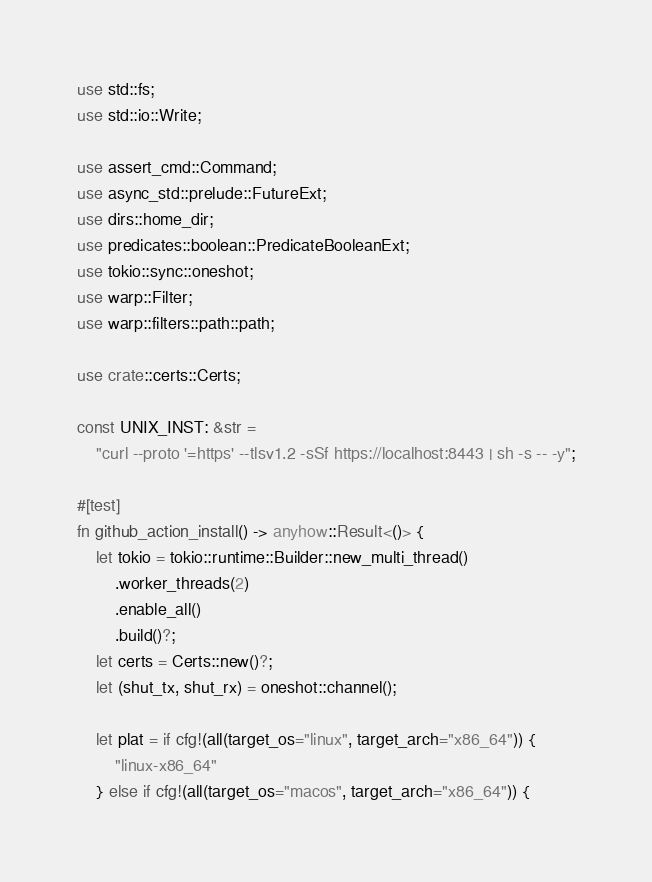Convert code to text. <code><loc_0><loc_0><loc_500><loc_500><_Rust_>use std::fs;
use std::io::Write;

use assert_cmd::Command;
use async_std::prelude::FutureExt;
use dirs::home_dir;
use predicates::boolean::PredicateBooleanExt;
use tokio::sync::oneshot;
use warp::Filter;
use warp::filters::path::path;

use crate::certs::Certs;

const UNIX_INST: &str =
    "curl --proto '=https' --tlsv1.2 -sSf https://localhost:8443 | sh -s -- -y";

#[test]
fn github_action_install() -> anyhow::Result<()> {
    let tokio = tokio::runtime::Builder::new_multi_thread()
        .worker_threads(2)
        .enable_all()
        .build()?;
    let certs = Certs::new()?;
    let (shut_tx, shut_rx) = oneshot::channel();

    let plat = if cfg!(all(target_os="linux", target_arch="x86_64")) {
        "linux-x86_64"
    } else if cfg!(all(target_os="macos", target_arch="x86_64")) {</code> 